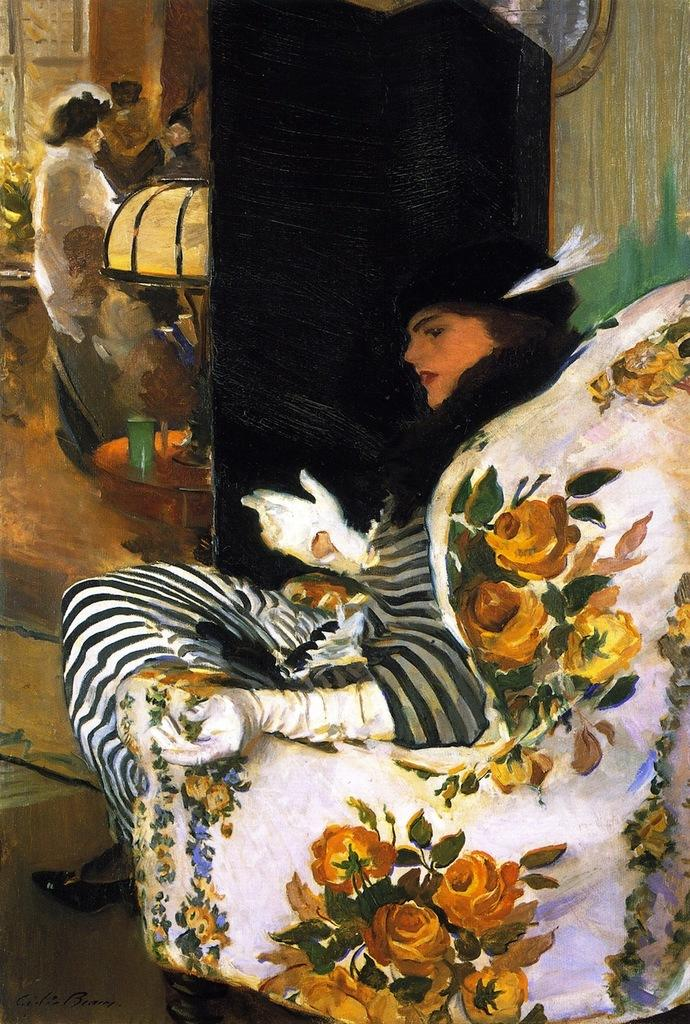What is the main subject of the image? There is a painting in the image. What type of laborer can be seen working in the painting? There is no laborer present in the image, as it only features a painting. How many rabbits are visible in the painting? There are no rabbits present in the image, as it only features a painting. 